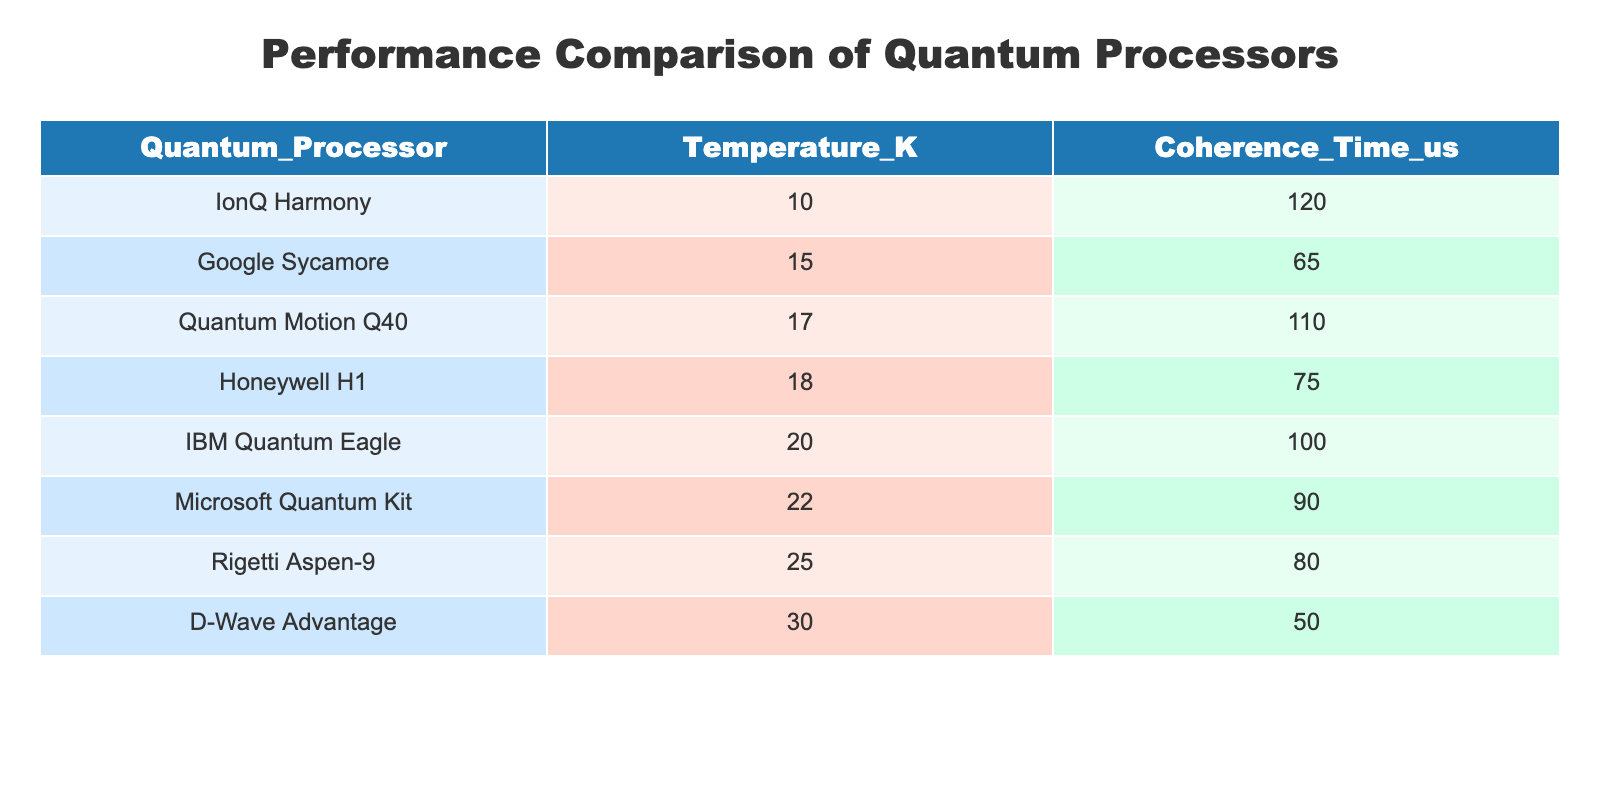What is the Coherence Time of the Google Sycamore processor? The table lists the Coherence Time for each quantum processor. For Google Sycamore, it shows 65 microseconds.
Answer: 65 microseconds Which quantum processor operates at the highest temperature? Looking through the Temperature_K column in the table, D-Wave Advantage has the highest recorded temperature at 30 Kelvin.
Answer: D-Wave Advantage What is the average Coherence Time of the processors listed? To find the average Coherence Time, add all the Coherence Times: 100 + 65 + 80 + 120 + 50 + 90 + 75 + 110 = 790 microseconds. Then, divide by the number of processors (8): 790/8 = 98.75 microseconds.
Answer: 98.75 microseconds Is the Coherence Time of IonQ Harmony greater than that of IBM Quantum Eagle? The Coherence Time of IonQ Harmony is 120 microseconds, while that of IBM Quantum Eagle is 100 microseconds. Since 120 is greater than 100, the answer is yes.
Answer: Yes Which two processors have a Coherence Time below 80 microseconds? Reviewing the Coherence Time values, D-Wave Advantage has 50 microseconds and Google Sycamore has 65 microseconds. Thus, these two processors meet the criteria.
Answer: D-Wave Advantage and Google Sycamore What is the difference in Coherence Time between Honeywell H1 and Quantum Motion Q40? From the table, Honeywell H1 has a Coherence Time of 75 microseconds, and Quantum Motion Q40 has 110 microseconds. The difference is 110 - 75 = 35 microseconds.
Answer: 35 microseconds Which processor has a Coherence Time closest to the average value? The average Coherence Time is 98.75 microseconds. Upon checking the table, IBM Quantum Eagle at 100 microseconds is the closest to the average.
Answer: IBM Quantum Eagle How many processors have a Coherence Time greater than 80 microseconds? The table lists all processors with their respective Coherence Times. The ones greater than 80 microseconds are IBM Quantum Eagle (100), IonQ Harmony (120), Microsoft Quantum Kit (90), and Quantum Motion Q40 (110). Therefore, there are four processors.
Answer: Four processors 